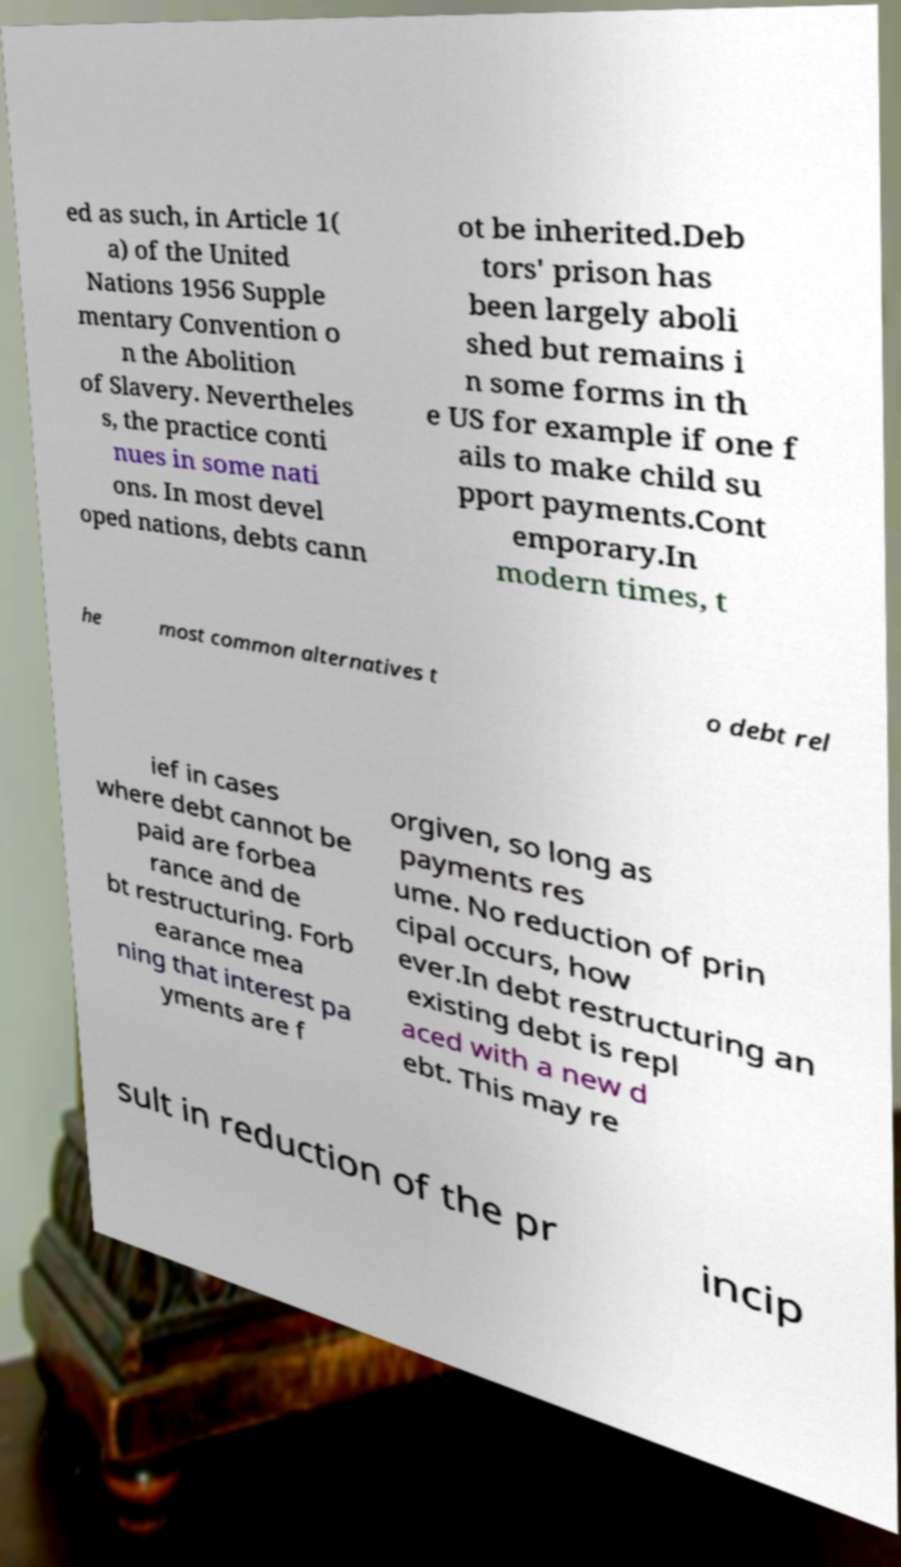I need the written content from this picture converted into text. Can you do that? ed as such, in Article 1( a) of the United Nations 1956 Supple mentary Convention o n the Abolition of Slavery. Nevertheles s, the practice conti nues in some nati ons. In most devel oped nations, debts cann ot be inherited.Deb tors' prison has been largely aboli shed but remains i n some forms in th e US for example if one f ails to make child su pport payments.Cont emporary.In modern times, t he most common alternatives t o debt rel ief in cases where debt cannot be paid are forbea rance and de bt restructuring. Forb earance mea ning that interest pa yments are f orgiven, so long as payments res ume. No reduction of prin cipal occurs, how ever.In debt restructuring an existing debt is repl aced with a new d ebt. This may re sult in reduction of the pr incip 